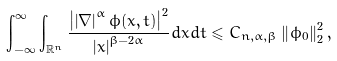Convert formula to latex. <formula><loc_0><loc_0><loc_500><loc_500>\int _ { - \infty } ^ { \infty } \int _ { \mathbb { R } ^ { n } } \frac { \left | \left | \nabla \right | ^ { \alpha } \phi ( x , t ) \right | ^ { 2 } } { \left | x \right | ^ { \beta - 2 \alpha } } d x d t \leqslant C _ { n , \alpha , \beta } \left \| \phi _ { 0 } \right \| _ { 2 } ^ { 2 } ,</formula> 